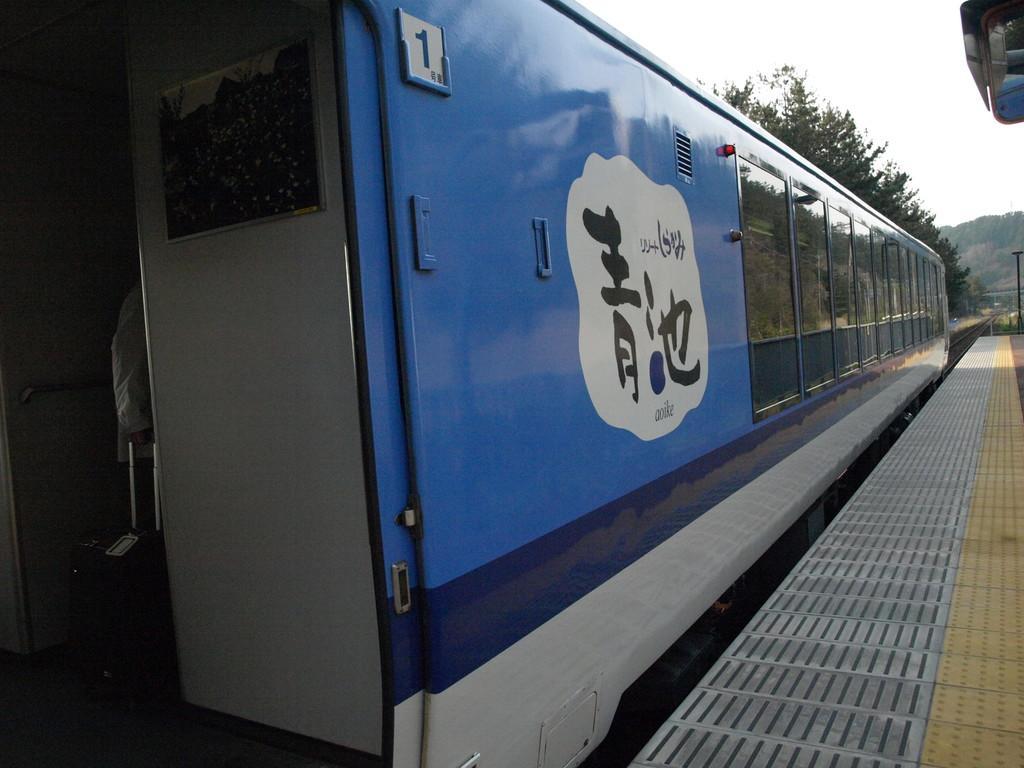Could you give a brief overview of what you see in this image? In this image we can see a train, inside the train it looks like a trolley bag and a person near the trolley bag and there is a platform near the train and in the background there are few trees, mountains and the sky. 